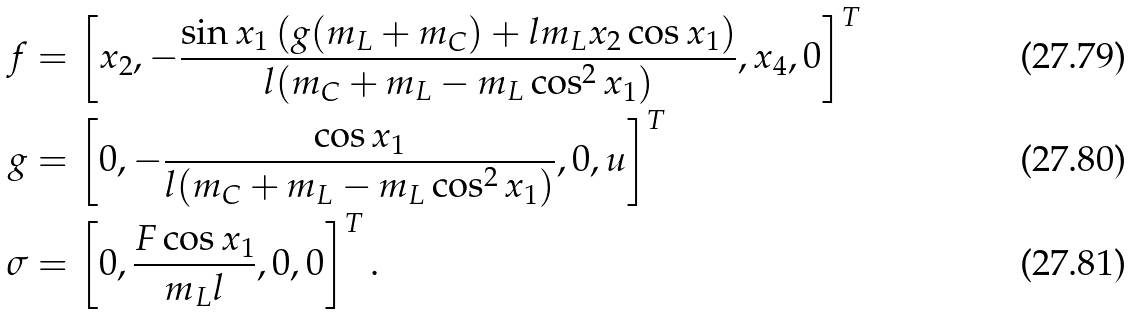<formula> <loc_0><loc_0><loc_500><loc_500>f & = \left [ x _ { 2 } , - \frac { \sin x _ { 1 } \left ( g ( m _ { L } + m _ { C } ) + l m _ { L } x _ { 2 } \cos x _ { 1 } \right ) } { l ( m _ { C } + m _ { L } - m _ { L } \cos ^ { 2 } x _ { 1 } ) } , x _ { 4 } , 0 \right ] ^ { T } \\ g & = \left [ 0 , - \frac { \cos x _ { 1 } } { l ( m _ { C } + m _ { L } - m _ { L } \cos ^ { 2 } x _ { 1 } ) } , 0 , u \right ] ^ { T } \\ \sigma & = \left [ 0 , \frac { F \cos x _ { 1 } } { m _ { L } l } , 0 , 0 \right ] ^ { T } .</formula> 